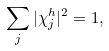<formula> <loc_0><loc_0><loc_500><loc_500>\sum _ { j } | \chi _ { j } ^ { h } | ^ { 2 } = 1 ,</formula> 